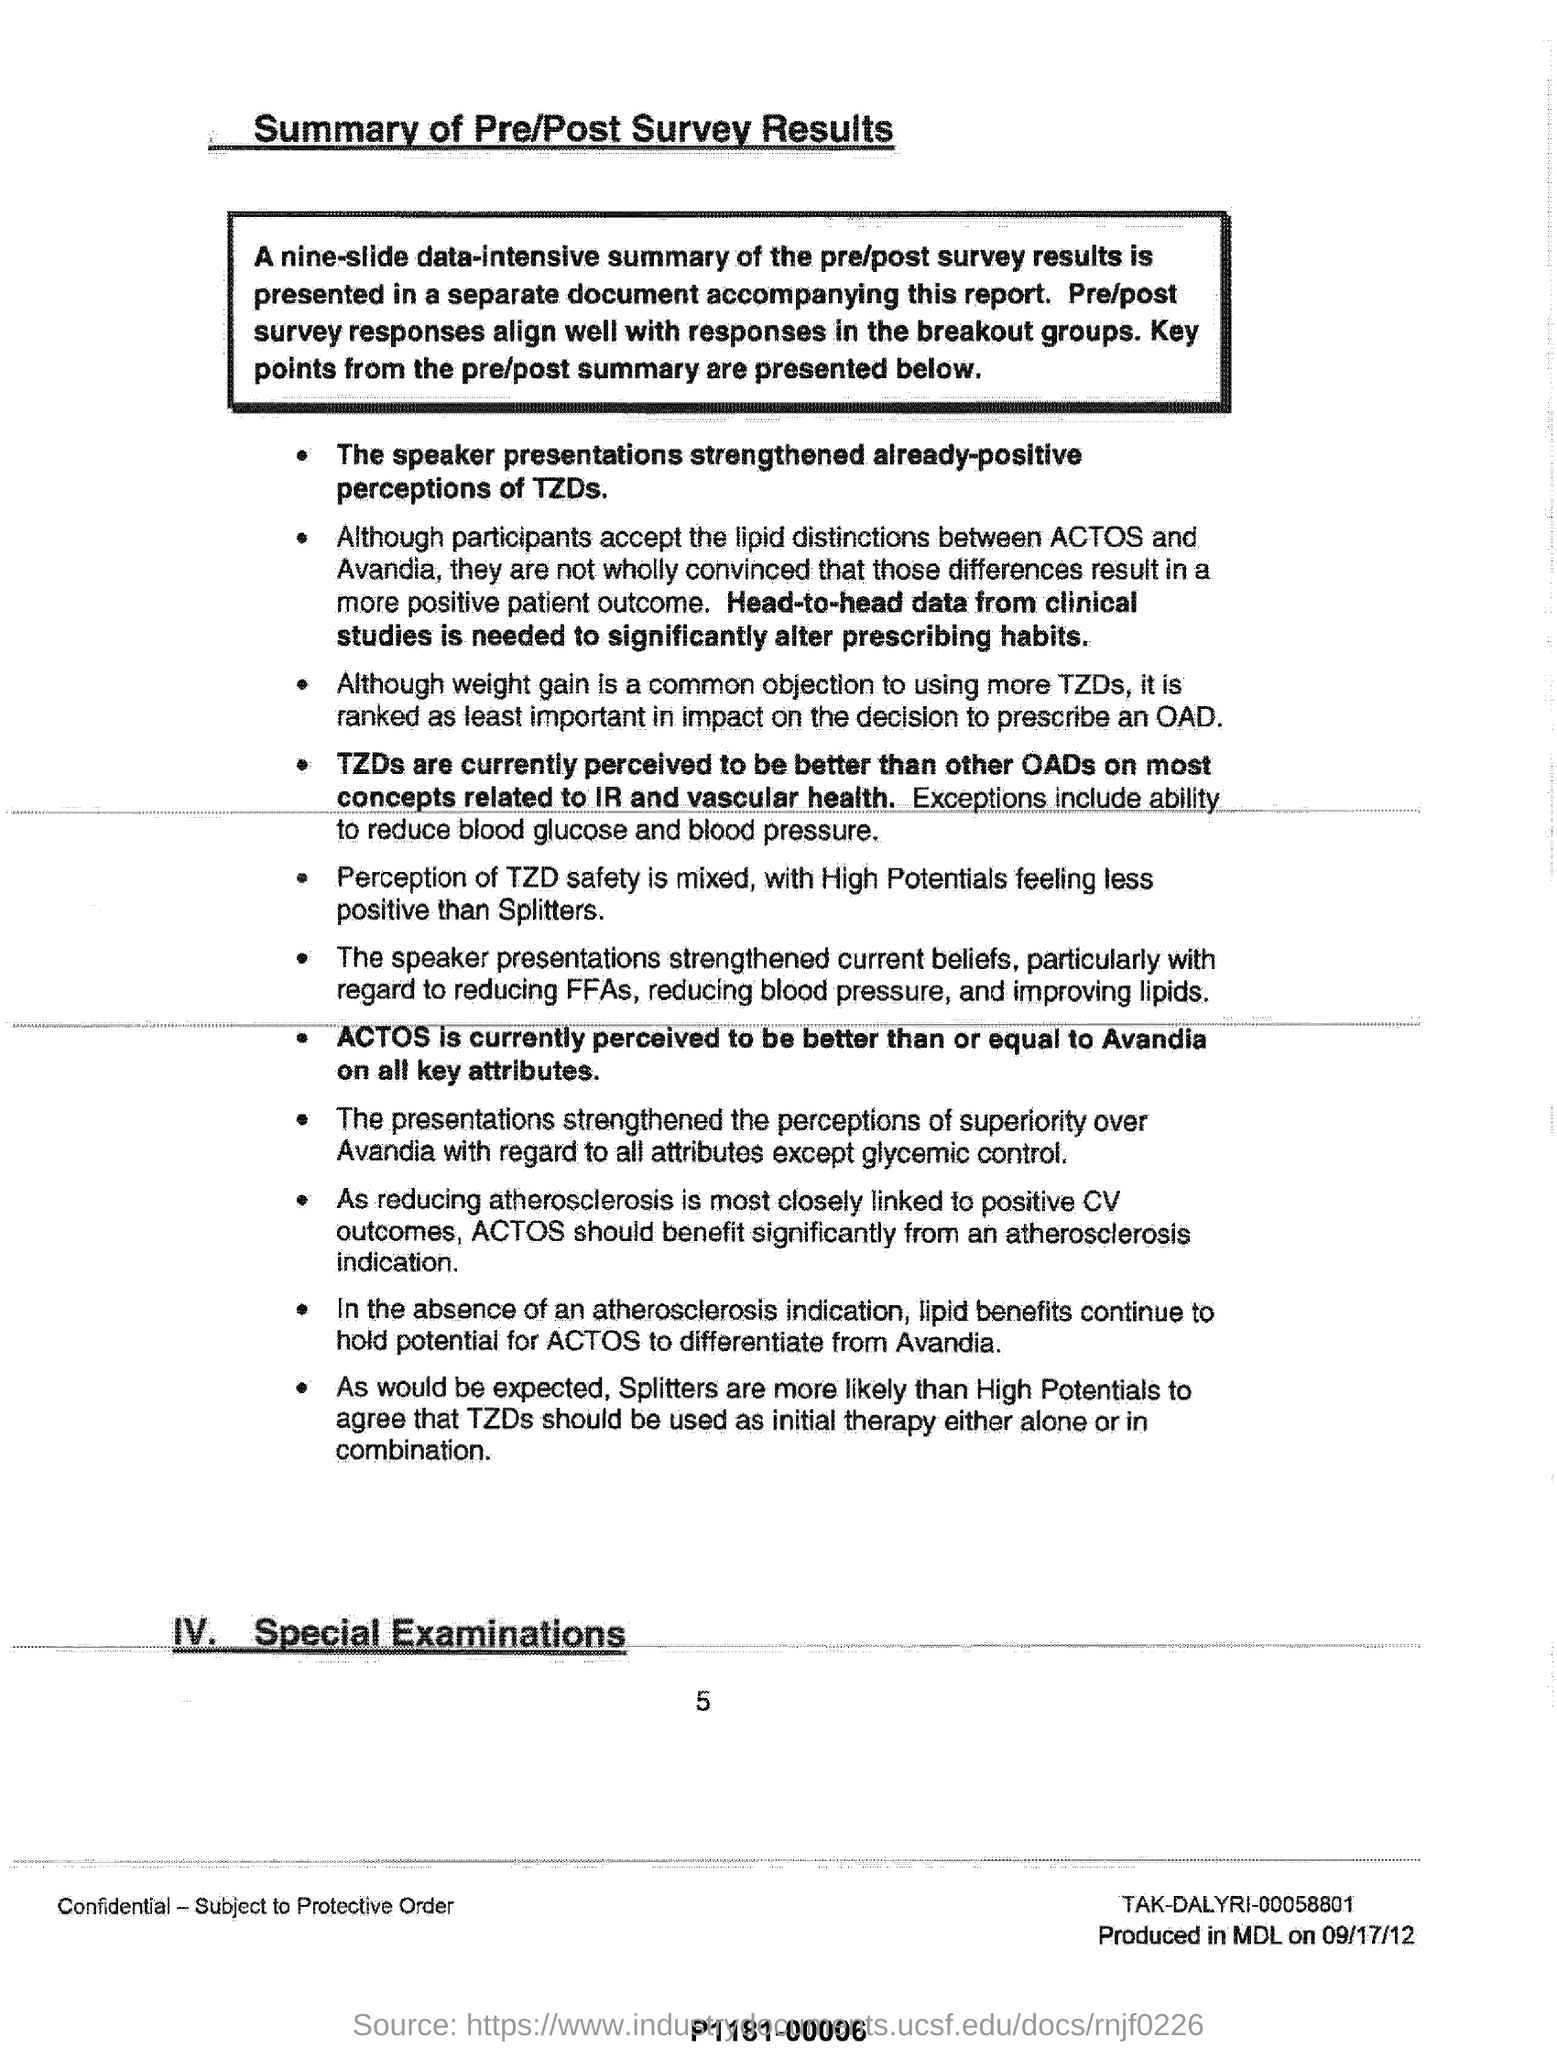What has strengthened the already-positive perceptions of TZDs?
Give a very brief answer. The speaker presentations. Which data is needed to significantly alter prescribing habits?
Keep it short and to the point. Head-to-head data from clinical studies. What is currently perceived to be better than or equal to Avandia on all key attributes?
Offer a terse response. ACTOS. 